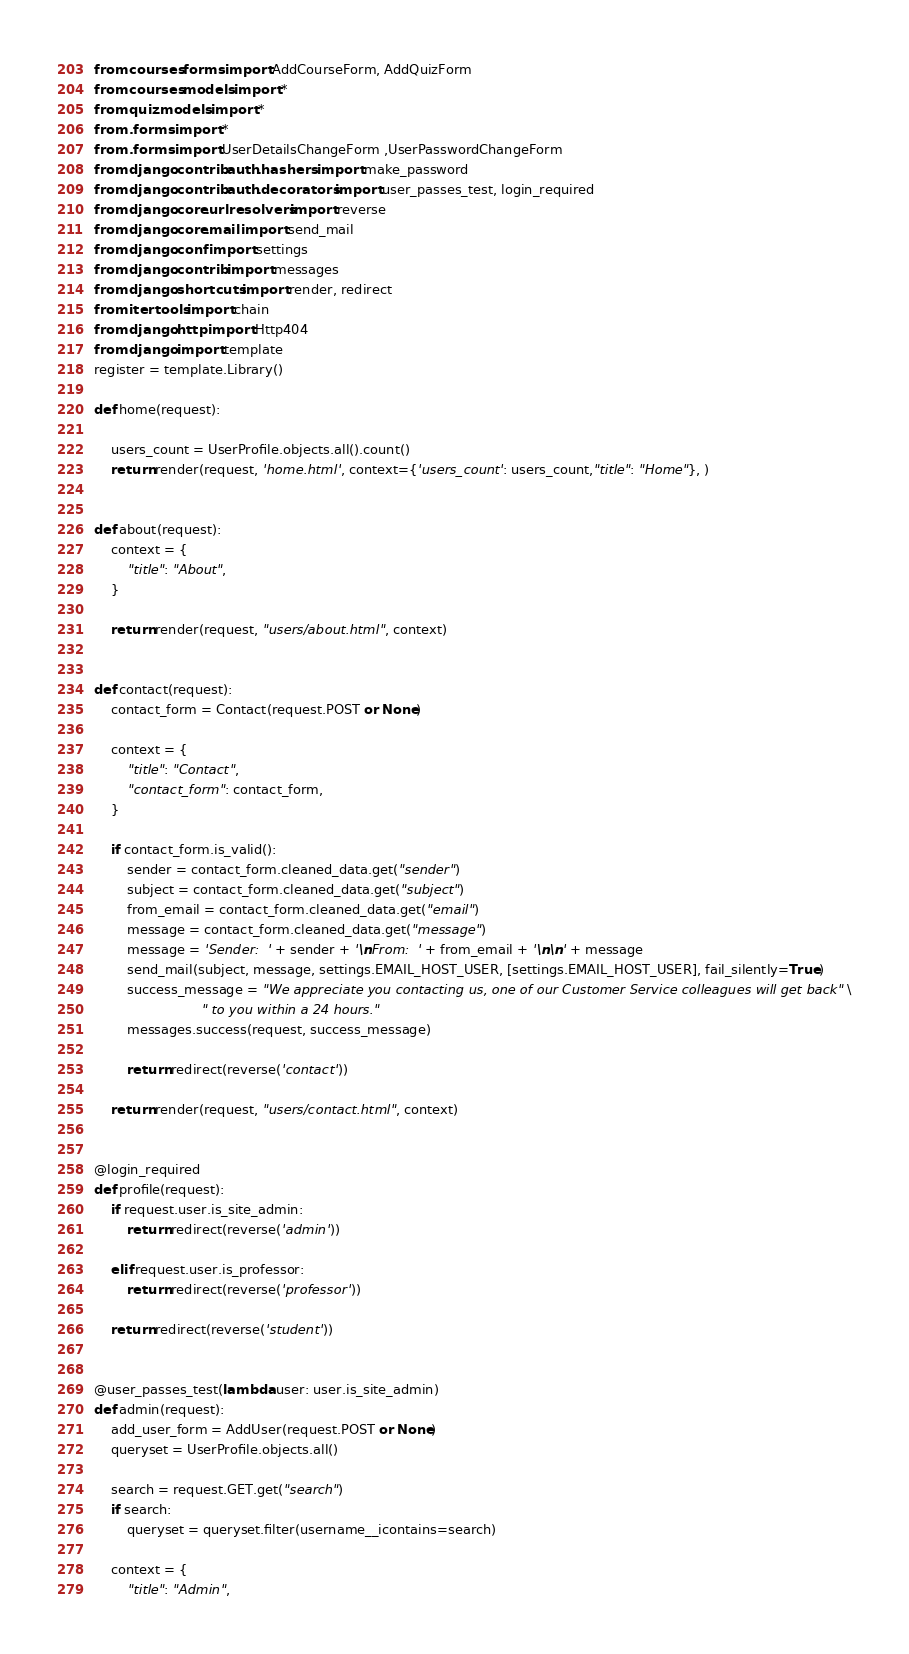<code> <loc_0><loc_0><loc_500><loc_500><_Python_>from courses.forms import AddCourseForm, AddQuizForm
from courses.models import *
from quiz.models import *
from .forms import *
from .forms import UserDetailsChangeForm ,UserPasswordChangeForm
from django.contrib.auth.hashers import make_password
from django.contrib.auth.decorators import user_passes_test, login_required
from django.core.urlresolvers import reverse
from django.core.mail import send_mail
from django.conf import settings
from django.contrib import messages
from django.shortcuts import render, redirect
from itertools import chain
from django.http import Http404
from django import template
register = template.Library()

def home(request):
   
    users_count = UserProfile.objects.all().count()
    return render(request, 'home.html', context={'users_count': users_count,"title": "Home"}, )


def about(request):
    context = {
        "title": "About",
    }

    return render(request, "users/about.html", context)


def contact(request):
    contact_form = Contact(request.POST or None)

    context = {
        "title": "Contact",
        "contact_form": contact_form,
    }

    if contact_form.is_valid():
        sender = contact_form.cleaned_data.get("sender")
        subject = contact_form.cleaned_data.get("subject")
        from_email = contact_form.cleaned_data.get("email")
        message = contact_form.cleaned_data.get("message")
        message = 'Sender:  ' + sender + '\nFrom:  ' + from_email + '\n\n' + message
        send_mail(subject, message, settings.EMAIL_HOST_USER, [settings.EMAIL_HOST_USER], fail_silently=True)
        success_message = "We appreciate you contacting us, one of our Customer Service colleagues will get back" \
                          " to you within a 24 hours."
        messages.success(request, success_message)

        return redirect(reverse('contact'))

    return render(request, "users/contact.html", context)


@login_required
def profile(request):
    if request.user.is_site_admin:
        return redirect(reverse('admin'))

    elif request.user.is_professor:
        return redirect(reverse('professor'))

    return redirect(reverse('student'))


@user_passes_test(lambda user: user.is_site_admin)
def admin(request):
    add_user_form = AddUser(request.POST or None)
    queryset = UserProfile.objects.all()

    search = request.GET.get("search")
    if search:
        queryset = queryset.filter(username__icontains=search)

    context = {
        "title": "Admin",</code> 